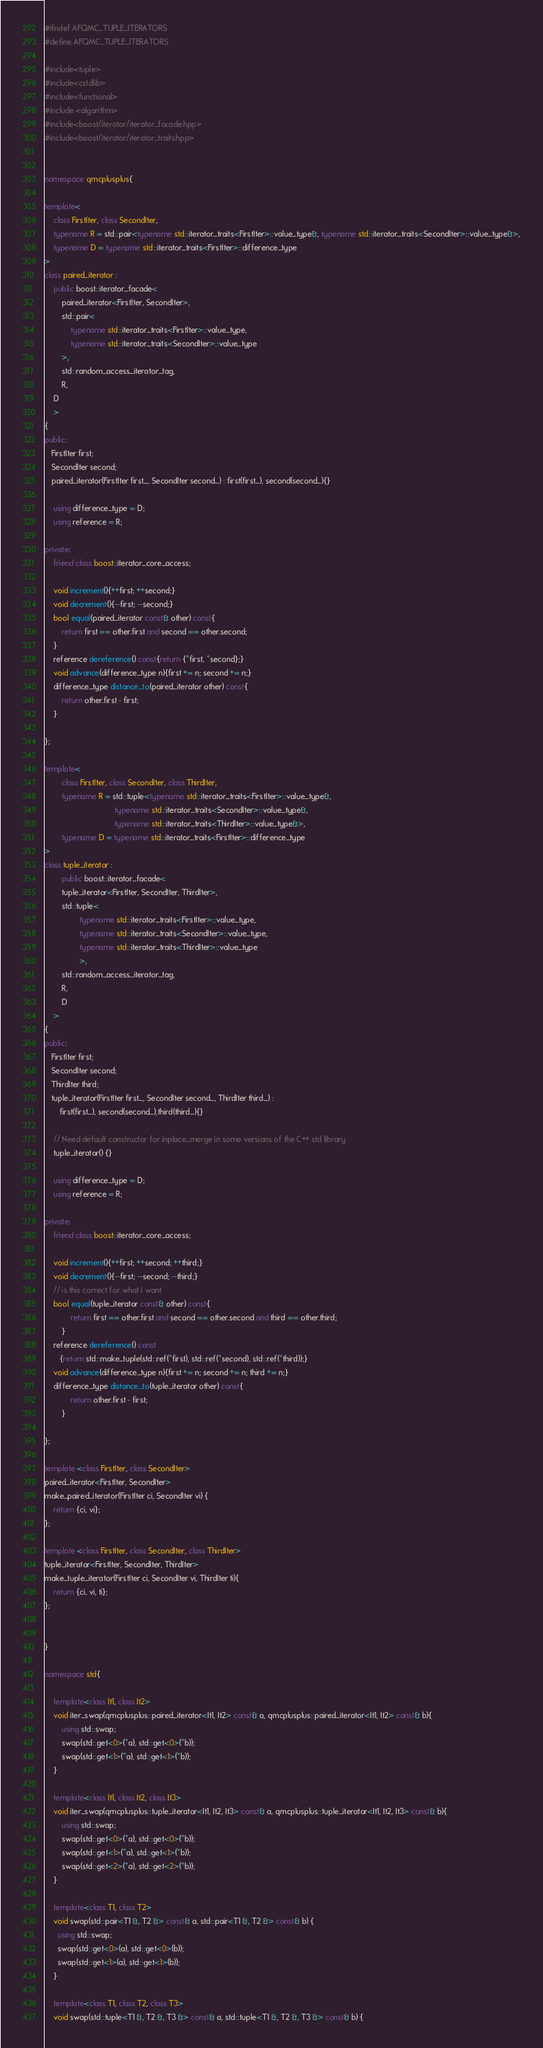Convert code to text. <code><loc_0><loc_0><loc_500><loc_500><_C++_>#ifndef AFQMC_TUPLE_ITERATORS
#define AFQMC_TUPLE_ITERATORS

#include<tuple>
#include<cstdlib>
#include<functional>
#include <algorithm> 
#include<boost/iterator/iterator_facade.hpp>
#include<boost/iterator/iterator_traits.hpp>


namespace qmcplusplus{

template<
	class FirstIter, class SecondIter, 
	typename R = std::pair<typename std::iterator_traits<FirstIter>::value_type&, typename std::iterator_traits<SecondIter>::value_type&>,
	typename D = typename std::iterator_traits<FirstIter>::difference_type
>
class paired_iterator : 
	public boost::iterator_facade<
        paired_iterator<FirstIter, SecondIter>,
     	std::pair<
	        typename std::iterator_traits<FirstIter>::value_type,
  	    	typename std::iterator_traits<SecondIter>::value_type 
		>,
        std::random_access_iterator_tag,
        R,
	D
    >
{
public:
   FirstIter first;
   SecondIter second;
   paired_iterator(FirstIter first_, SecondIter second_) : first(first_), second(second_){}

    using difference_type = D;
    using reference = R;

private:
    friend class boost::iterator_core_access;

    void increment(){++first; ++second;}
    void decrement(){--first; --second;}
    bool equal(paired_iterator const& other) const{
	    return first == other.first and second == other.second;
	}
    reference dereference() const{return {*first, *second};} 
    void advance(difference_type n){first += n; second += n;}
    difference_type distance_to(paired_iterator other) const{
	    return other.first - first;
	}

};

template<
        class FirstIter, class SecondIter, class ThirdIter,
        typename R = std::tuple<typename std::iterator_traits<FirstIter>::value_type&, 
                                typename std::iterator_traits<SecondIter>::value_type&,
                                typename std::iterator_traits<ThirdIter>::value_type&>,
        typename D = typename std::iterator_traits<FirstIter>::difference_type
>
class tuple_iterator :
        public boost::iterator_facade<
        tuple_iterator<FirstIter, SecondIter, ThirdIter>,
        std::tuple<
                typename std::iterator_traits<FirstIter>::value_type,
                typename std::iterator_traits<SecondIter>::value_type,
                typename std::iterator_traits<ThirdIter>::value_type
                >,
        std::random_access_iterator_tag,
        R,
        D
    >
{
public:
   FirstIter first;
   SecondIter second;
   ThirdIter third;
   tuple_iterator(FirstIter first_, SecondIter second_, ThirdIter third_) :
       first(first_), second(second_),third(third_){}

    // Need default constructor for inplace_merge in some versions of the C++ std library
    tuple_iterator() {}

    using difference_type = D;
    using reference = R;

private:
    friend class boost::iterator_core_access;

    void increment(){++first; ++second; ++third;}
    void decrement(){--first; --second; --third;}
    // is this correct for what I want
    bool equal(tuple_iterator const& other) const{
            return first == other.first and second == other.second and third == other.third;
        }
    reference dereference() const
       {return std::make_tuple(std::ref(*first), std::ref(*second), std::ref(*third));}
    void advance(difference_type n){first += n; second += n; third += n;}
    difference_type distance_to(tuple_iterator other) const{
            return other.first - first;
        }

};

template <class FirstIter, class SecondIter>
paired_iterator<FirstIter, SecondIter>
make_paired_iterator(FirstIter ci, SecondIter vi) {
    return {ci, vi};
};

template <class FirstIter, class SecondIter, class ThirdIter>
tuple_iterator<FirstIter, SecondIter, ThirdIter>
make_tuple_iterator(FirstIter ci, SecondIter vi, ThirdIter ti){
    return {ci, vi, ti};
};


}

namespace std{

    template<class It1, class It2>
    void iter_swap(qmcplusplus::paired_iterator<It1, It2> const& a, qmcplusplus::paired_iterator<It1, It2> const& b){
        using std::swap;
        swap(std::get<0>(*a), std::get<0>(*b));
        swap(std::get<1>(*a), std::get<1>(*b));
    }

    template<class It1, class It2, class It3>
    void iter_swap(qmcplusplus::tuple_iterator<It1, It2, It3> const& a, qmcplusplus::tuple_iterator<It1, It2, It3> const& b){
        using std::swap;
        swap(std::get<0>(*a), std::get<0>(*b));
        swap(std::get<1>(*a), std::get<1>(*b));
        swap(std::get<2>(*a), std::get<2>(*b));
    }

    template<class T1, class T2>
    void swap(std::pair<T1 &, T2 &> const& a, std::pair<T1 &, T2 &> const& b) {
      using std::swap;
      swap(std::get<0>(a), std::get<0>(b));
      swap(std::get<1>(a), std::get<1>(b));
    }

    template<class T1, class T2, class T3>
    void swap(std::tuple<T1 &, T2 &, T3 &> const& a, std::tuple<T1 &, T2 &, T3 &> const& b) {</code> 